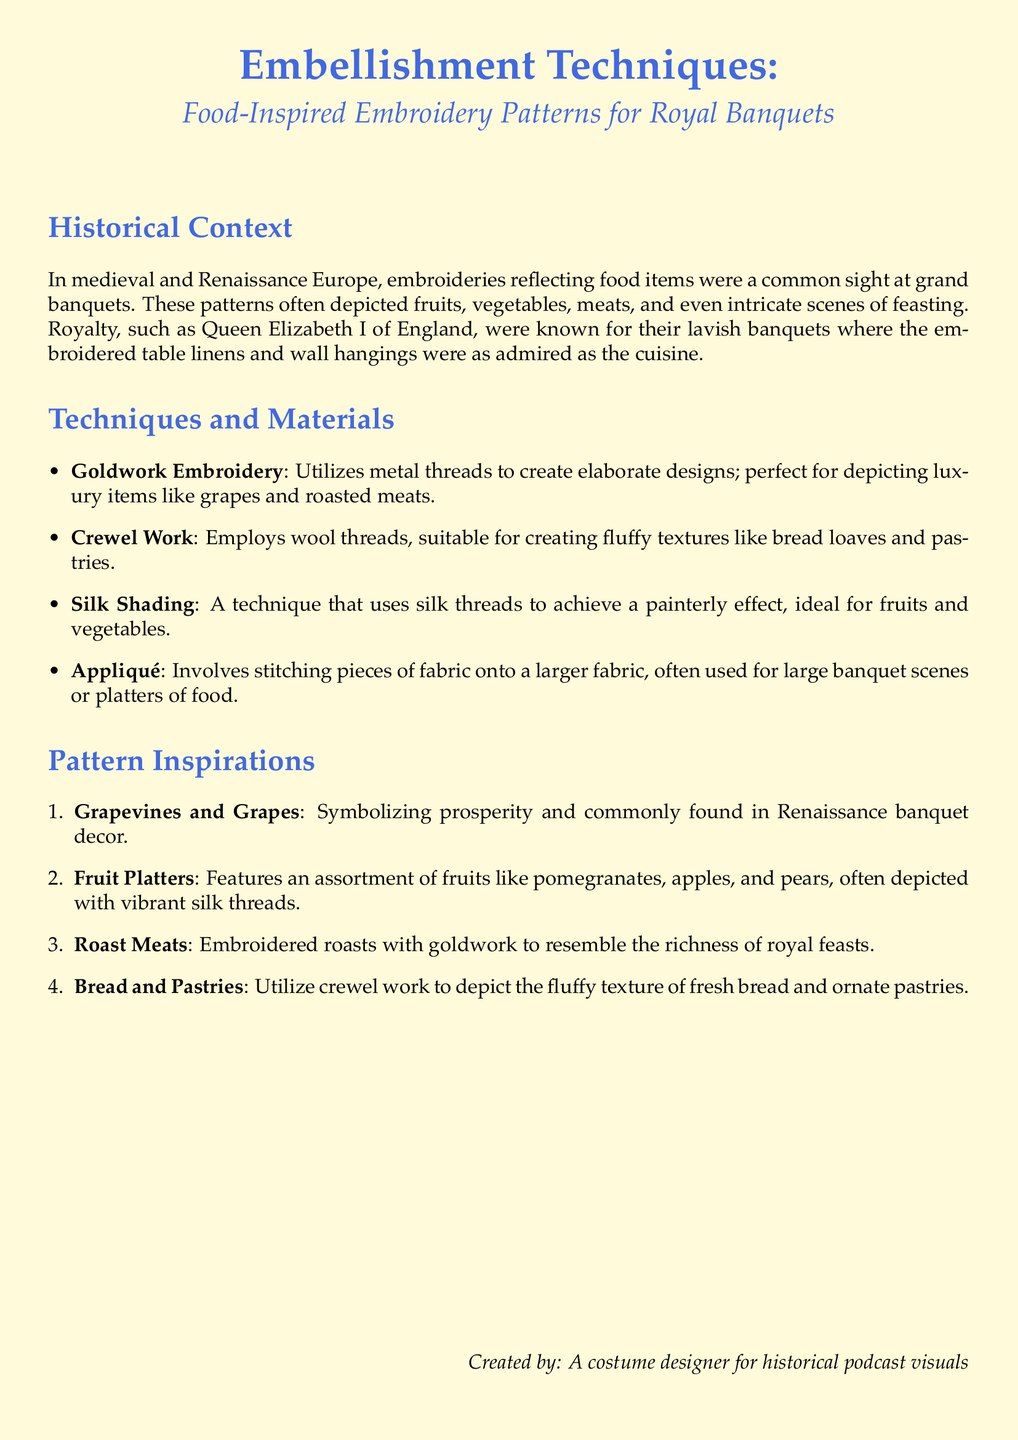What is the main theme of the document? The document discusses embellishment techniques using food-inspired embroidery patterns for royal banquets.
Answer: Food-inspired embroidery patterns Who is known for lavish banquets with embroidered decor? The document mentions Queen Elizabeth I as a figure known for her lavish banquets and decorated table linens.
Answer: Queen Elizabeth I What embroidery technique makes use of metal threads? The document lists Goldwork Embroidery as a technique that utilizes metal threads for designs.
Answer: Goldwork Embroidery Which pattern features fruits like pomegranates and pears? The section on Pattern Inspirations describes the Fruit Platters as featuring an assortment of fruits.
Answer: Fruit Platters What technique is suitable for depicting fluffy textures? The document states that Crewel Work is employed to create fluffy textures such as bread loaves and pastries.
Answer: Crewel Work How many embellishment techniques are mentioned in the document? The document lists four different techniques used in the embroidery patterns.
Answer: Four What type of materials is used in Silk Shading? The document specifies that Silk Shading uses silk threads to achieve a particular effect.
Answer: Silk threads What does Appliqué involve? The document explains that Appliqué involves stitching pieces of fabric onto a larger fabric.
Answer: Stitching pieces of fabric What is represented by grapevines in the document? The document indicates that grapevines symbolize prosperity in Renaissance banquet decor.
Answer: Prosperity 